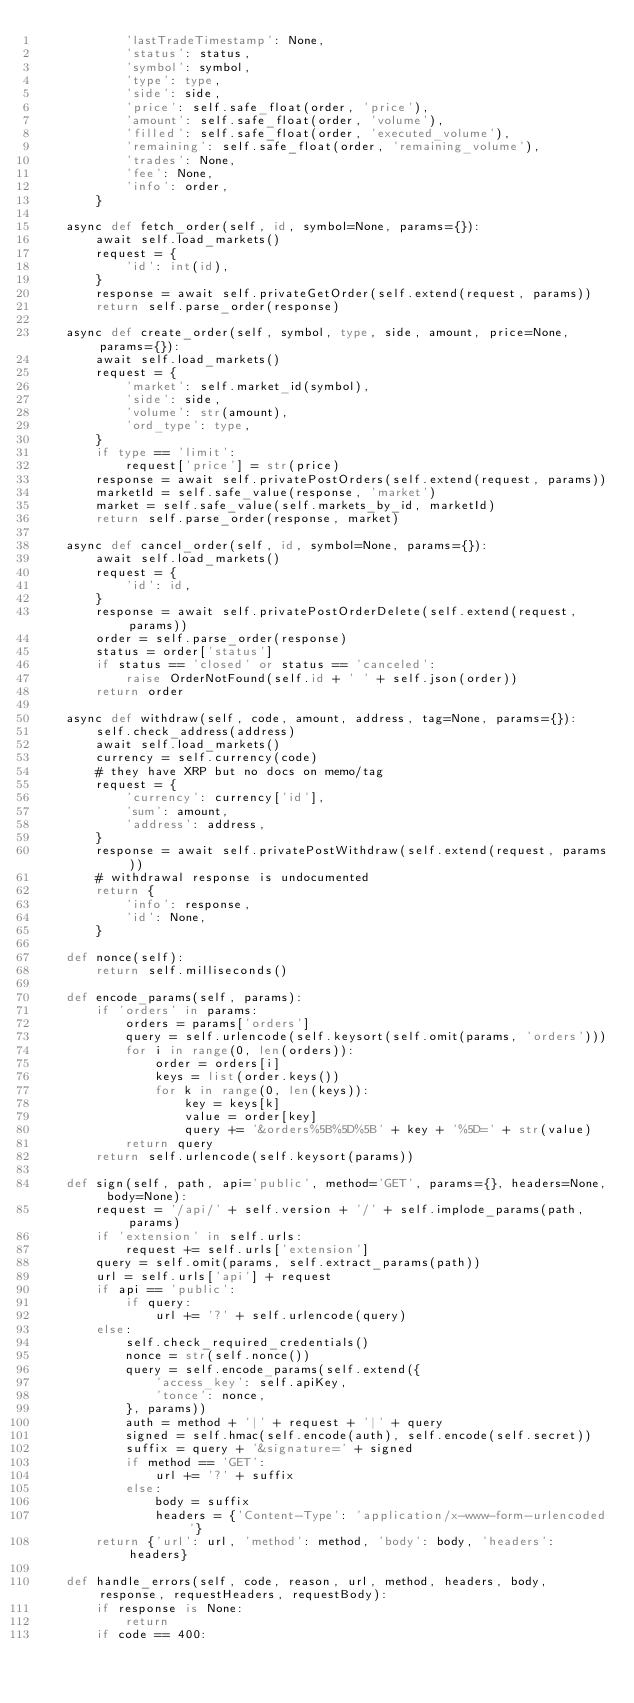Convert code to text. <code><loc_0><loc_0><loc_500><loc_500><_Python_>            'lastTradeTimestamp': None,
            'status': status,
            'symbol': symbol,
            'type': type,
            'side': side,
            'price': self.safe_float(order, 'price'),
            'amount': self.safe_float(order, 'volume'),
            'filled': self.safe_float(order, 'executed_volume'),
            'remaining': self.safe_float(order, 'remaining_volume'),
            'trades': None,
            'fee': None,
            'info': order,
        }

    async def fetch_order(self, id, symbol=None, params={}):
        await self.load_markets()
        request = {
            'id': int(id),
        }
        response = await self.privateGetOrder(self.extend(request, params))
        return self.parse_order(response)

    async def create_order(self, symbol, type, side, amount, price=None, params={}):
        await self.load_markets()
        request = {
            'market': self.market_id(symbol),
            'side': side,
            'volume': str(amount),
            'ord_type': type,
        }
        if type == 'limit':
            request['price'] = str(price)
        response = await self.privatePostOrders(self.extend(request, params))
        marketId = self.safe_value(response, 'market')
        market = self.safe_value(self.markets_by_id, marketId)
        return self.parse_order(response, market)

    async def cancel_order(self, id, symbol=None, params={}):
        await self.load_markets()
        request = {
            'id': id,
        }
        response = await self.privatePostOrderDelete(self.extend(request, params))
        order = self.parse_order(response)
        status = order['status']
        if status == 'closed' or status == 'canceled':
            raise OrderNotFound(self.id + ' ' + self.json(order))
        return order

    async def withdraw(self, code, amount, address, tag=None, params={}):
        self.check_address(address)
        await self.load_markets()
        currency = self.currency(code)
        # they have XRP but no docs on memo/tag
        request = {
            'currency': currency['id'],
            'sum': amount,
            'address': address,
        }
        response = await self.privatePostWithdraw(self.extend(request, params))
        # withdrawal response is undocumented
        return {
            'info': response,
            'id': None,
        }

    def nonce(self):
        return self.milliseconds()

    def encode_params(self, params):
        if 'orders' in params:
            orders = params['orders']
            query = self.urlencode(self.keysort(self.omit(params, 'orders')))
            for i in range(0, len(orders)):
                order = orders[i]
                keys = list(order.keys())
                for k in range(0, len(keys)):
                    key = keys[k]
                    value = order[key]
                    query += '&orders%5B%5D%5B' + key + '%5D=' + str(value)
            return query
        return self.urlencode(self.keysort(params))

    def sign(self, path, api='public', method='GET', params={}, headers=None, body=None):
        request = '/api/' + self.version + '/' + self.implode_params(path, params)
        if 'extension' in self.urls:
            request += self.urls['extension']
        query = self.omit(params, self.extract_params(path))
        url = self.urls['api'] + request
        if api == 'public':
            if query:
                url += '?' + self.urlencode(query)
        else:
            self.check_required_credentials()
            nonce = str(self.nonce())
            query = self.encode_params(self.extend({
                'access_key': self.apiKey,
                'tonce': nonce,
            }, params))
            auth = method + '|' + request + '|' + query
            signed = self.hmac(self.encode(auth), self.encode(self.secret))
            suffix = query + '&signature=' + signed
            if method == 'GET':
                url += '?' + suffix
            else:
                body = suffix
                headers = {'Content-Type': 'application/x-www-form-urlencoded'}
        return {'url': url, 'method': method, 'body': body, 'headers': headers}

    def handle_errors(self, code, reason, url, method, headers, body, response, requestHeaders, requestBody):
        if response is None:
            return
        if code == 400:</code> 